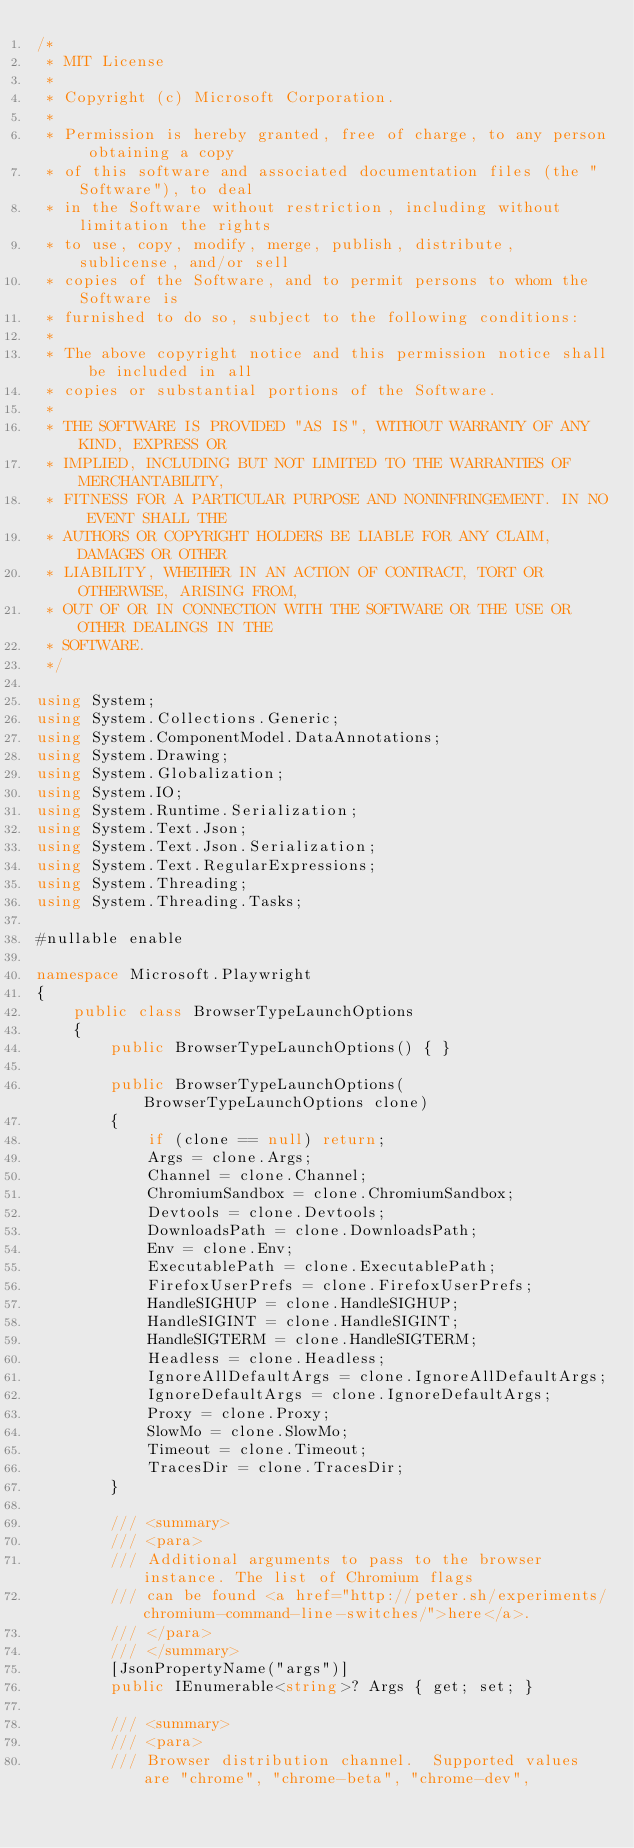<code> <loc_0><loc_0><loc_500><loc_500><_C#_>/*
 * MIT License
 *
 * Copyright (c) Microsoft Corporation.
 *
 * Permission is hereby granted, free of charge, to any person obtaining a copy
 * of this software and associated documentation files (the "Software"), to deal
 * in the Software without restriction, including without limitation the rights
 * to use, copy, modify, merge, publish, distribute, sublicense, and/or sell
 * copies of the Software, and to permit persons to whom the Software is
 * furnished to do so, subject to the following conditions:
 *
 * The above copyright notice and this permission notice shall be included in all
 * copies or substantial portions of the Software.
 *
 * THE SOFTWARE IS PROVIDED "AS IS", WITHOUT WARRANTY OF ANY KIND, EXPRESS OR
 * IMPLIED, INCLUDING BUT NOT LIMITED TO THE WARRANTIES OF MERCHANTABILITY,
 * FITNESS FOR A PARTICULAR PURPOSE AND NONINFRINGEMENT. IN NO EVENT SHALL THE
 * AUTHORS OR COPYRIGHT HOLDERS BE LIABLE FOR ANY CLAIM, DAMAGES OR OTHER
 * LIABILITY, WHETHER IN AN ACTION OF CONTRACT, TORT OR OTHERWISE, ARISING FROM,
 * OUT OF OR IN CONNECTION WITH THE SOFTWARE OR THE USE OR OTHER DEALINGS IN THE
 * SOFTWARE.
 */

using System;
using System.Collections.Generic;
using System.ComponentModel.DataAnnotations;
using System.Drawing;
using System.Globalization;
using System.IO;
using System.Runtime.Serialization;
using System.Text.Json;
using System.Text.Json.Serialization;
using System.Text.RegularExpressions;
using System.Threading;
using System.Threading.Tasks;

#nullable enable

namespace Microsoft.Playwright
{
    public class BrowserTypeLaunchOptions
    {
        public BrowserTypeLaunchOptions() { }

        public BrowserTypeLaunchOptions(BrowserTypeLaunchOptions clone)
        {
            if (clone == null) return;
            Args = clone.Args;
            Channel = clone.Channel;
            ChromiumSandbox = clone.ChromiumSandbox;
            Devtools = clone.Devtools;
            DownloadsPath = clone.DownloadsPath;
            Env = clone.Env;
            ExecutablePath = clone.ExecutablePath;
            FirefoxUserPrefs = clone.FirefoxUserPrefs;
            HandleSIGHUP = clone.HandleSIGHUP;
            HandleSIGINT = clone.HandleSIGINT;
            HandleSIGTERM = clone.HandleSIGTERM;
            Headless = clone.Headless;
            IgnoreAllDefaultArgs = clone.IgnoreAllDefaultArgs;
            IgnoreDefaultArgs = clone.IgnoreDefaultArgs;
            Proxy = clone.Proxy;
            SlowMo = clone.SlowMo;
            Timeout = clone.Timeout;
            TracesDir = clone.TracesDir;
        }

        /// <summary>
        /// <para>
        /// Additional arguments to pass to the browser instance. The list of Chromium flags
        /// can be found <a href="http://peter.sh/experiments/chromium-command-line-switches/">here</a>.
        /// </para>
        /// </summary>
        [JsonPropertyName("args")]
        public IEnumerable<string>? Args { get; set; }

        /// <summary>
        /// <para>
        /// Browser distribution channel.  Supported values are "chrome", "chrome-beta", "chrome-dev",</code> 